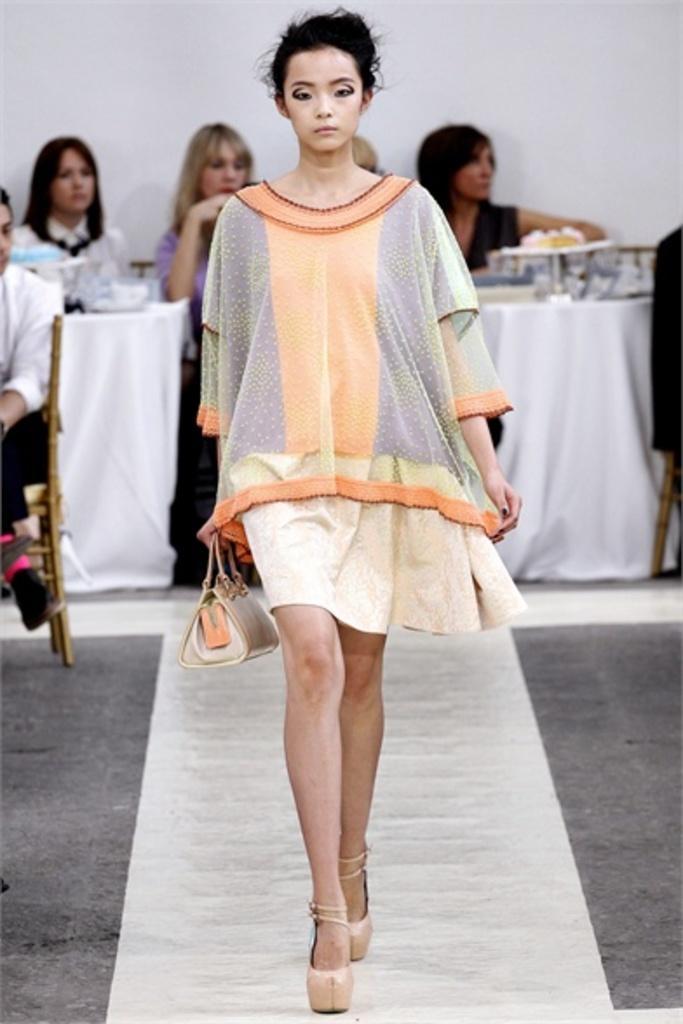Describe this image in one or two sentences. In the center of the image we can see a lady walking. In the background there are people sitting and we can see tables. There are things placed on the tables. There is a wall. 